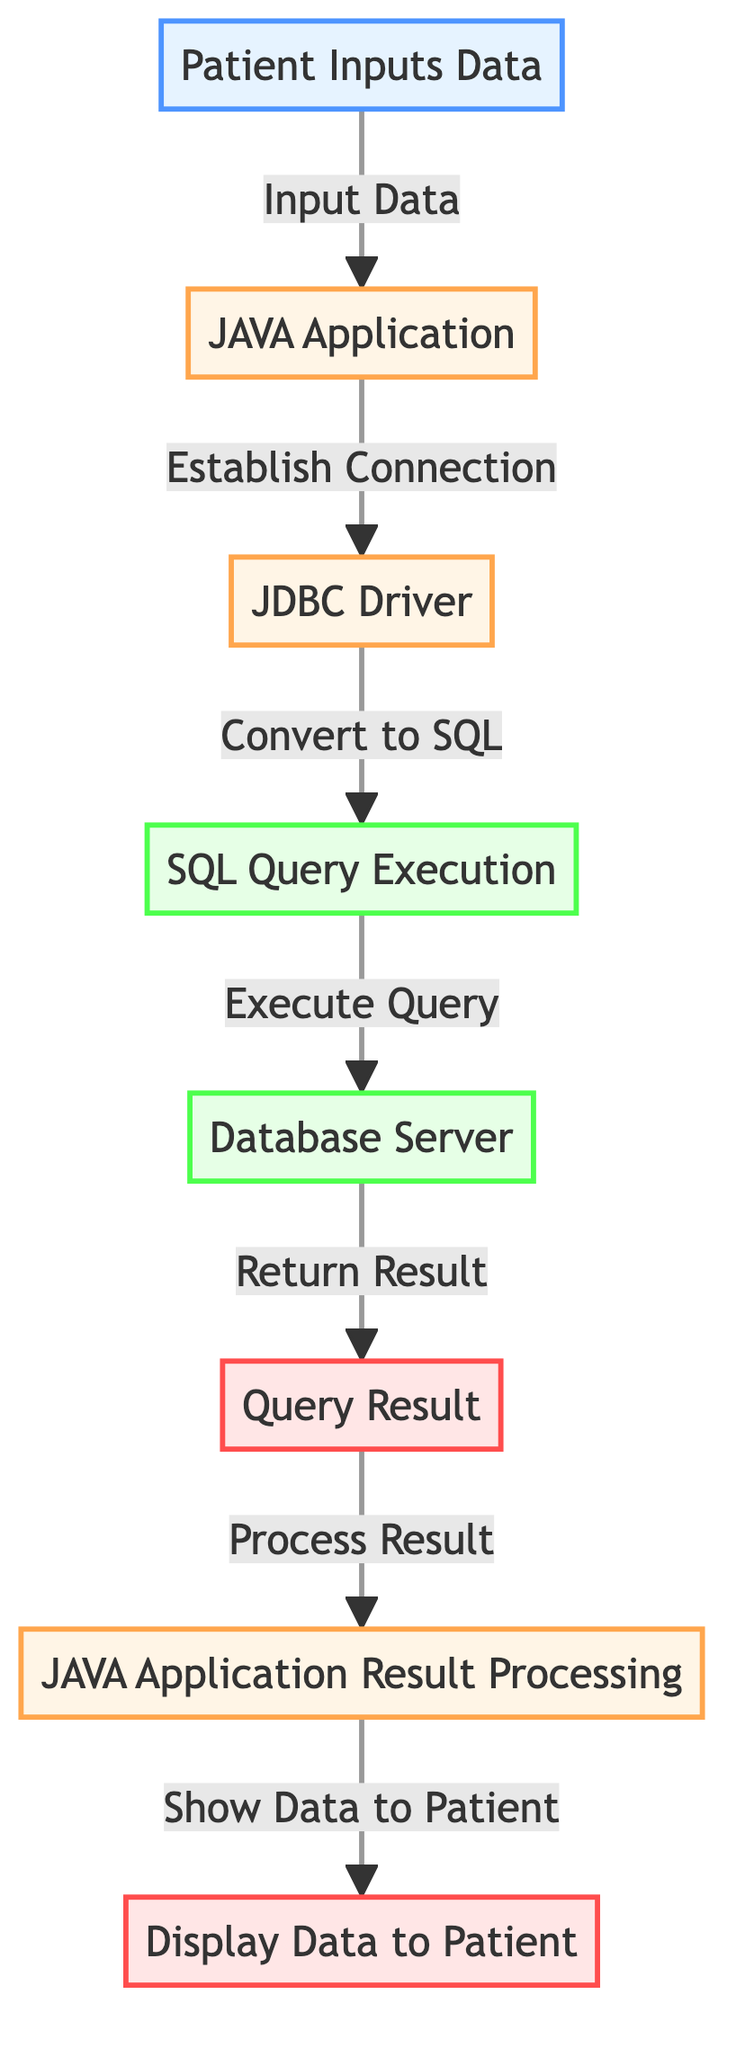What is the first step of the process? The first step is "Patient Inputs Data," which is the input node. This indicates that the process starts with the patient providing data.
Answer: Patient Inputs Data How many nodes are present in the diagram? The diagram contains 8 nodes, each representing a different stage in the Java database interaction process.
Answer: 8 What is the output of the process? The output at the end of the process is "Display Data to Patient." This shows the final stage where the processed results are shown to the patient.
Answer: Display Data to Patient Which node is responsible for establishing a connection? The "JAVA Application" node is responsible for establishing a connection, as it directly connects to the "JDBC Driver."
Answer: JAVA Application What step follows SQL Query Execution? The step following "SQL Query Execution" is "Database Server," where the query is executed on the database.
Answer: Database Server How many database nodes are in the diagram? There are 2 database nodes: "SQL Query Execution" and "Database Server," indicating points where database interactions occur.
Answer: 2 What is the direct relationship between the JDBC Driver and SQL Query Execution? The JDBC Driver has a direct relationship with SQL Query Execution, as it converts the query to SQL format before execution.
Answer: Convert to SQL What happens to the Query Result? The Query Result is processed by the "JAVA Application Result Processing" node after it is received from the database server.
Answer: Process Result In total, how many edges connect the nodes? There are 7 edges connecting the nodes, showing the flow from the input to the output in the interaction process.
Answer: 7 